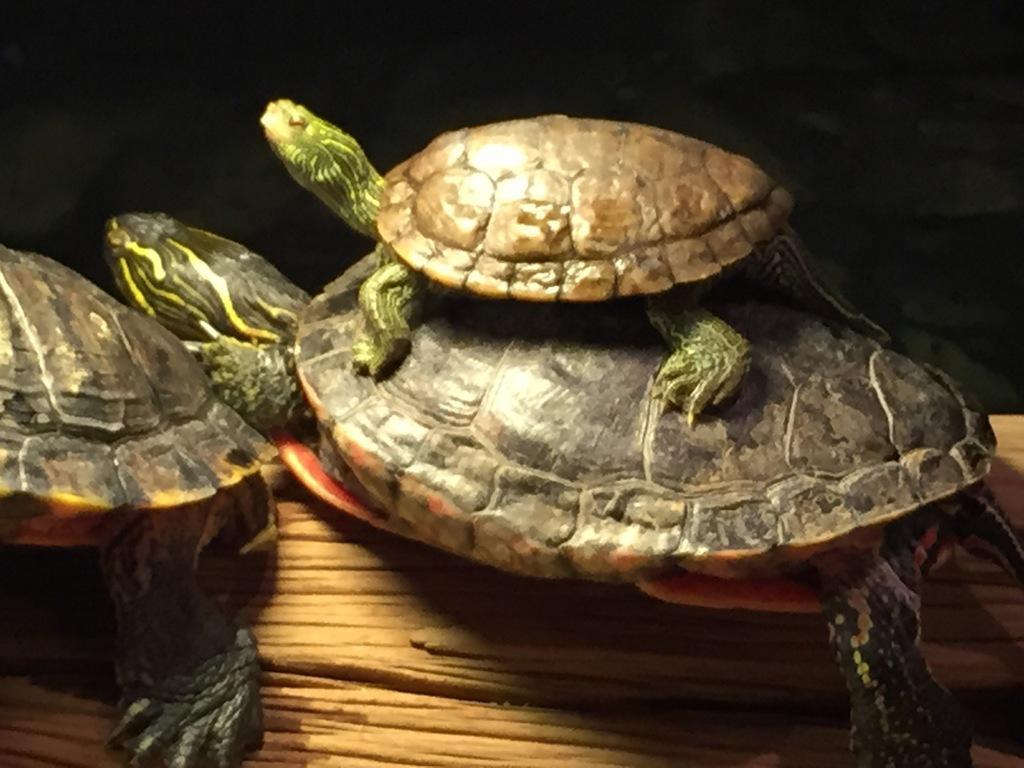Please provide a concise description of this image. In this image there are tortoise on a wooden surface, the background of the image is dark. 